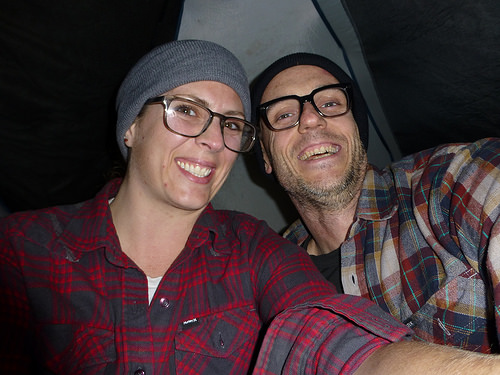<image>
Is the black shirt on the woman? No. The black shirt is not positioned on the woman. They may be near each other, but the black shirt is not supported by or resting on top of the woman. Is the woman next to the man? Yes. The woman is positioned adjacent to the man, located nearby in the same general area. 